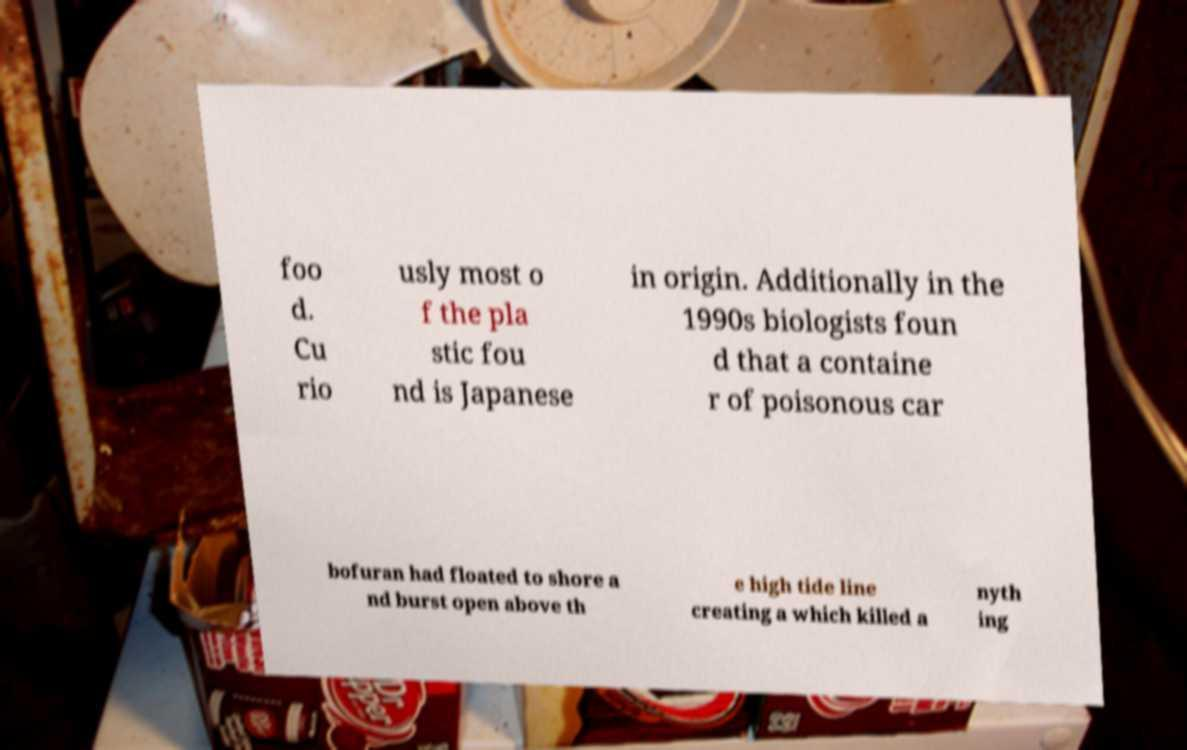I need the written content from this picture converted into text. Can you do that? foo d. Cu rio usly most o f the pla stic fou nd is Japanese in origin. Additionally in the 1990s biologists foun d that a containe r of poisonous car bofuran had floated to shore a nd burst open above th e high tide line creating a which killed a nyth ing 